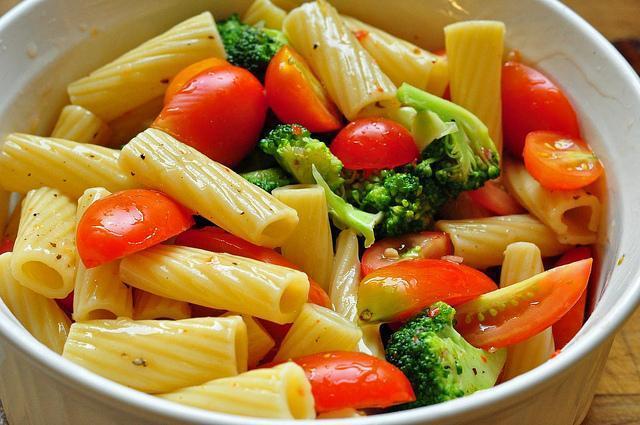How many  varieties of vegetables are in the pasta?
Give a very brief answer. 2. How many broccolis can be seen?
Give a very brief answer. 3. 